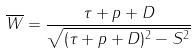Convert formula to latex. <formula><loc_0><loc_0><loc_500><loc_500>\overline { W } = \frac { \tau + p + D } { \sqrt { ( \tau + p + D ) ^ { 2 } - S ^ { 2 } } }</formula> 